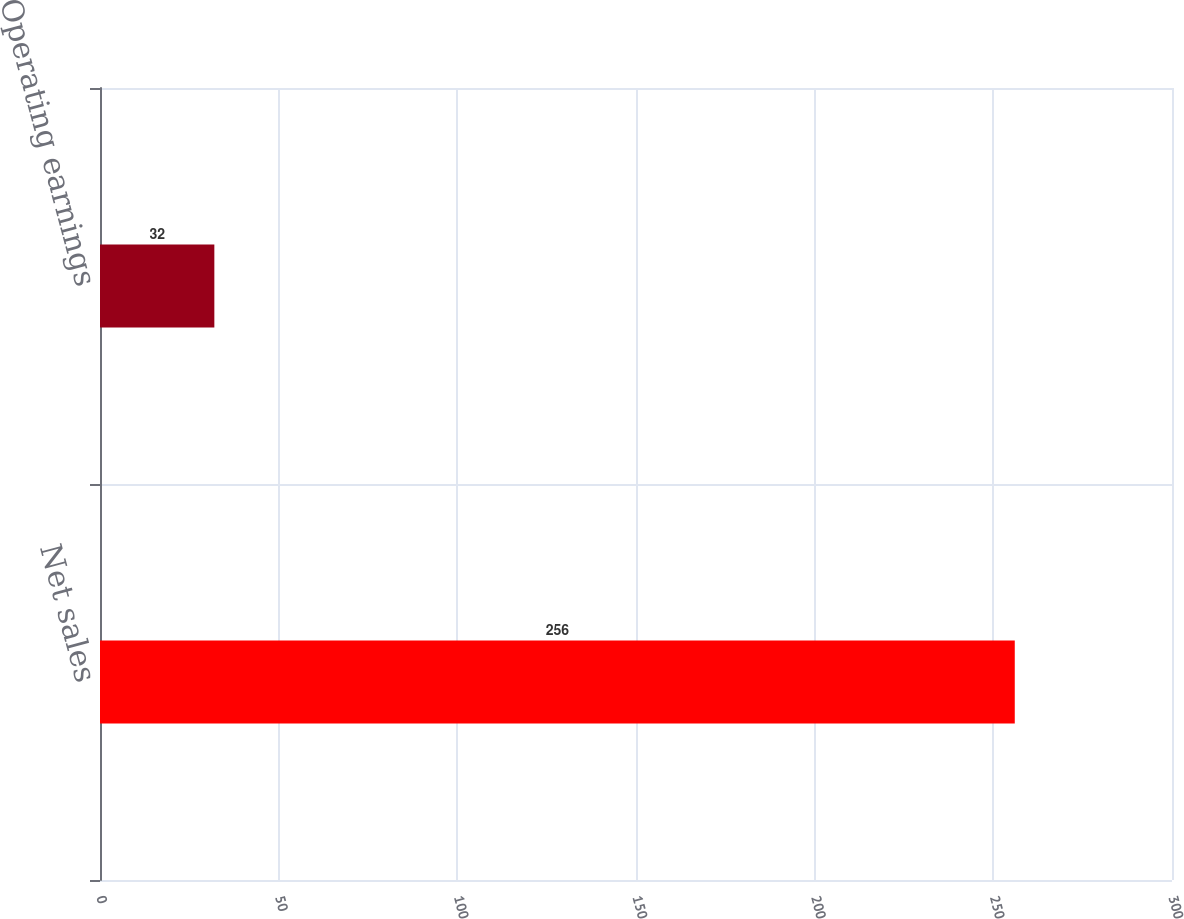<chart> <loc_0><loc_0><loc_500><loc_500><bar_chart><fcel>Net sales<fcel>Operating earnings<nl><fcel>256<fcel>32<nl></chart> 